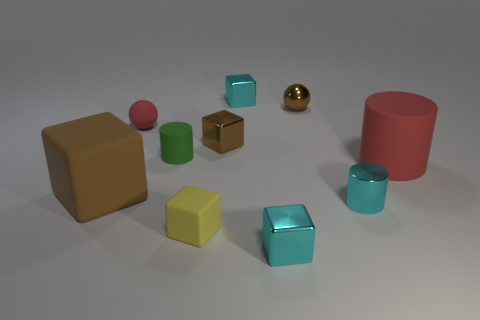Is the number of cyan metal things behind the brown ball greater than the number of metal blocks that are in front of the tiny cyan metal cylinder?
Ensure brevity in your answer.  No. What size is the brown sphere?
Ensure brevity in your answer.  Small. What shape is the tiny yellow object that is made of the same material as the green cylinder?
Your answer should be compact. Cube. Do the matte thing that is on the left side of the tiny red object and the tiny red matte thing have the same shape?
Keep it short and to the point. No. How many objects are cyan things or matte cylinders?
Provide a short and direct response. 5. There is a small object that is on the left side of the small brown shiny cube and in front of the big brown matte object; what is its material?
Your response must be concise. Rubber. Is the size of the green rubber object the same as the metallic ball?
Ensure brevity in your answer.  Yes. What is the size of the red rubber object in front of the matte cylinder that is to the left of the big cylinder?
Offer a terse response. Large. What number of tiny things are to the left of the tiny metallic sphere and behind the red matte ball?
Ensure brevity in your answer.  1. Are there any objects behind the large matte object on the left side of the tiny brown ball that is behind the green rubber cylinder?
Provide a succinct answer. Yes. 